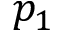Convert formula to latex. <formula><loc_0><loc_0><loc_500><loc_500>p _ { 1 }</formula> 